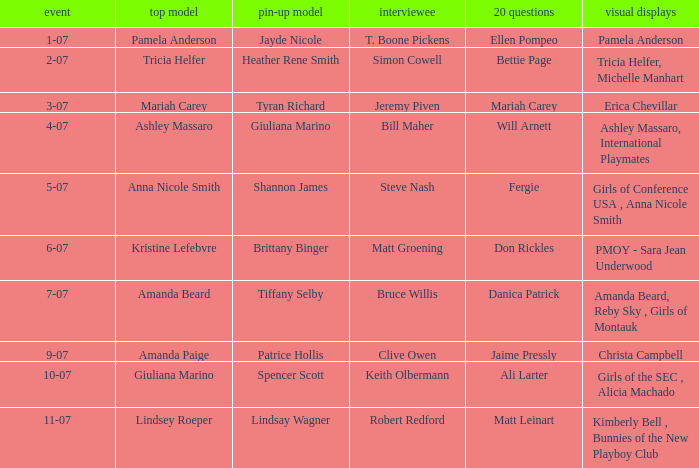Who was the centerfold model when the issue's pictorial was kimberly bell , bunnies of the new playboy club? Lindsay Wagner. 